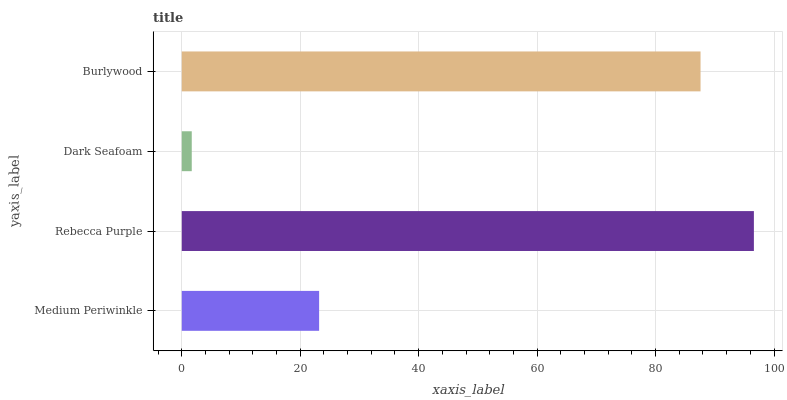Is Dark Seafoam the minimum?
Answer yes or no. Yes. Is Rebecca Purple the maximum?
Answer yes or no. Yes. Is Rebecca Purple the minimum?
Answer yes or no. No. Is Dark Seafoam the maximum?
Answer yes or no. No. Is Rebecca Purple greater than Dark Seafoam?
Answer yes or no. Yes. Is Dark Seafoam less than Rebecca Purple?
Answer yes or no. Yes. Is Dark Seafoam greater than Rebecca Purple?
Answer yes or no. No. Is Rebecca Purple less than Dark Seafoam?
Answer yes or no. No. Is Burlywood the high median?
Answer yes or no. Yes. Is Medium Periwinkle the low median?
Answer yes or no. Yes. Is Rebecca Purple the high median?
Answer yes or no. No. Is Burlywood the low median?
Answer yes or no. No. 